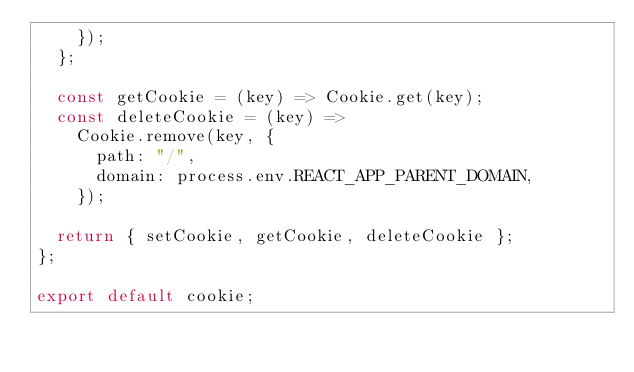<code> <loc_0><loc_0><loc_500><loc_500><_JavaScript_>    });
  };

  const getCookie = (key) => Cookie.get(key);
  const deleteCookie = (key) =>
    Cookie.remove(key, {
      path: "/",
      domain: process.env.REACT_APP_PARENT_DOMAIN,
    });

  return { setCookie, getCookie, deleteCookie };
};

export default cookie;
</code> 